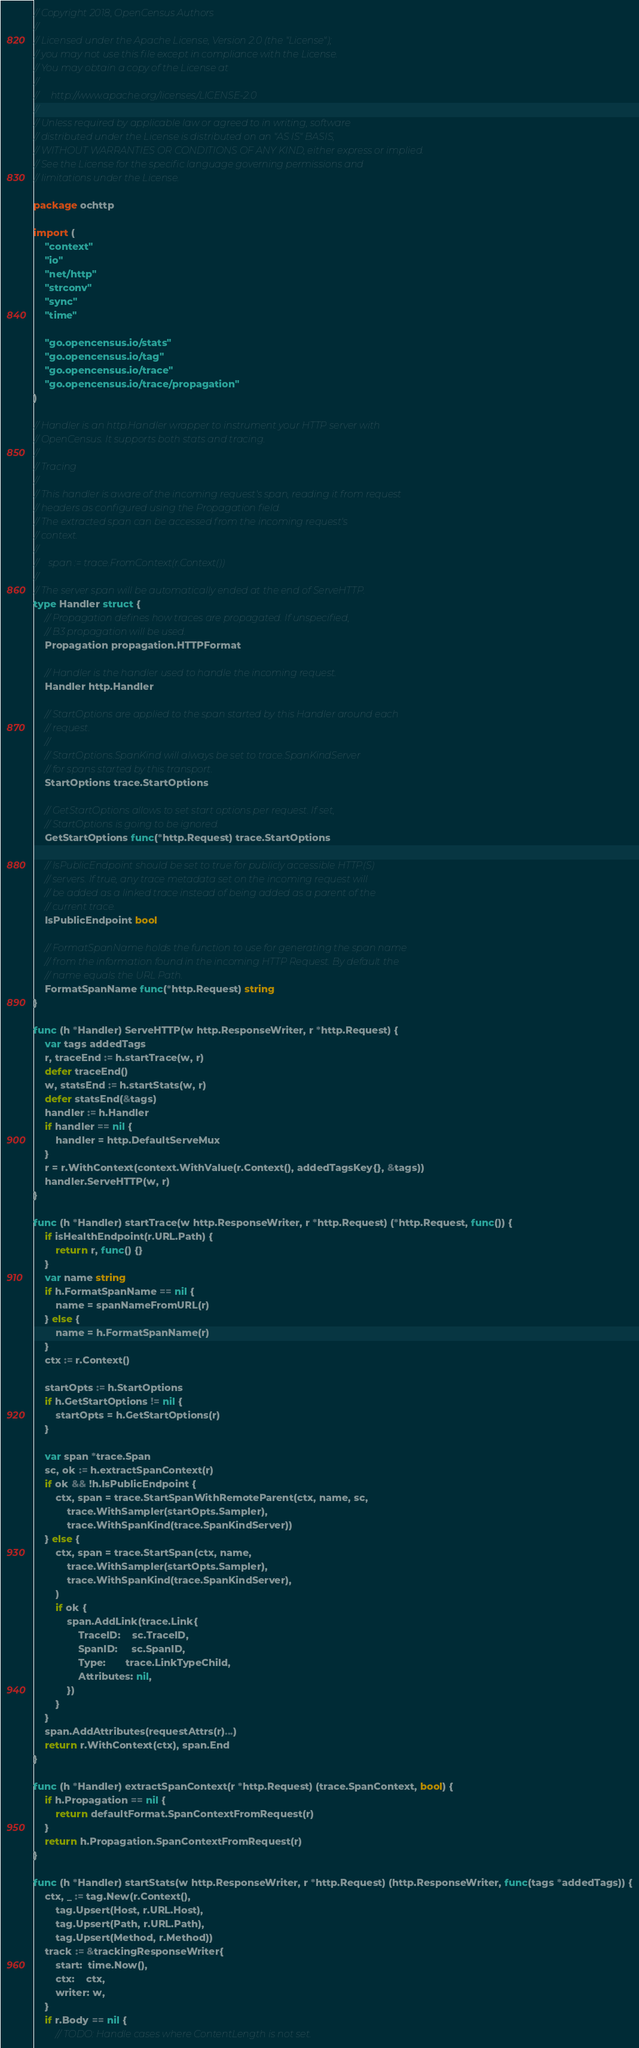<code> <loc_0><loc_0><loc_500><loc_500><_Go_>// Copyright 2018, OpenCensus Authors
//
// Licensed under the Apache License, Version 2.0 (the "License");
// you may not use this file except in compliance with the License.
// You may obtain a copy of the License at
//
//     http://www.apache.org/licenses/LICENSE-2.0
//
// Unless required by applicable law or agreed to in writing, software
// distributed under the License is distributed on an "AS IS" BASIS,
// WITHOUT WARRANTIES OR CONDITIONS OF ANY KIND, either express or implied.
// See the License for the specific language governing permissions and
// limitations under the License.

package ochttp

import (
	"context"
	"io"
	"net/http"
	"strconv"
	"sync"
	"time"

	"go.opencensus.io/stats"
	"go.opencensus.io/tag"
	"go.opencensus.io/trace"
	"go.opencensus.io/trace/propagation"
)

// Handler is an http.Handler wrapper to instrument your HTTP server with
// OpenCensus. It supports both stats and tracing.
//
// Tracing
//
// This handler is aware of the incoming request's span, reading it from request
// headers as configured using the Propagation field.
// The extracted span can be accessed from the incoming request's
// context.
//
//    span := trace.FromContext(r.Context())
//
// The server span will be automatically ended at the end of ServeHTTP.
type Handler struct {
	// Propagation defines how traces are propagated. If unspecified,
	// B3 propagation will be used.
	Propagation propagation.HTTPFormat

	// Handler is the handler used to handle the incoming request.
	Handler http.Handler

	// StartOptions are applied to the span started by this Handler around each
	// request.
	//
	// StartOptions.SpanKind will always be set to trace.SpanKindServer
	// for spans started by this transport.
	StartOptions trace.StartOptions

	// GetStartOptions allows to set start options per request. If set,
	// StartOptions is going to be ignored.
	GetStartOptions func(*http.Request) trace.StartOptions

	// IsPublicEndpoint should be set to true for publicly accessible HTTP(S)
	// servers. If true, any trace metadata set on the incoming request will
	// be added as a linked trace instead of being added as a parent of the
	// current trace.
	IsPublicEndpoint bool

	// FormatSpanName holds the function to use for generating the span name
	// from the information found in the incoming HTTP Request. By default the
	// name equals the URL Path.
	FormatSpanName func(*http.Request) string
}

func (h *Handler) ServeHTTP(w http.ResponseWriter, r *http.Request) {
	var tags addedTags
	r, traceEnd := h.startTrace(w, r)
	defer traceEnd()
	w, statsEnd := h.startStats(w, r)
	defer statsEnd(&tags)
	handler := h.Handler
	if handler == nil {
		handler = http.DefaultServeMux
	}
	r = r.WithContext(context.WithValue(r.Context(), addedTagsKey{}, &tags))
	handler.ServeHTTP(w, r)
}

func (h *Handler) startTrace(w http.ResponseWriter, r *http.Request) (*http.Request, func()) {
	if isHealthEndpoint(r.URL.Path) {
		return r, func() {}
	}
	var name string
	if h.FormatSpanName == nil {
		name = spanNameFromURL(r)
	} else {
		name = h.FormatSpanName(r)
	}
	ctx := r.Context()

	startOpts := h.StartOptions
	if h.GetStartOptions != nil {
		startOpts = h.GetStartOptions(r)
	}

	var span *trace.Span
	sc, ok := h.extractSpanContext(r)
	if ok && !h.IsPublicEndpoint {
		ctx, span = trace.StartSpanWithRemoteParent(ctx, name, sc,
			trace.WithSampler(startOpts.Sampler),
			trace.WithSpanKind(trace.SpanKindServer))
	} else {
		ctx, span = trace.StartSpan(ctx, name,
			trace.WithSampler(startOpts.Sampler),
			trace.WithSpanKind(trace.SpanKindServer),
		)
		if ok {
			span.AddLink(trace.Link{
				TraceID:    sc.TraceID,
				SpanID:     sc.SpanID,
				Type:       trace.LinkTypeChild,
				Attributes: nil,
			})
		}
	}
	span.AddAttributes(requestAttrs(r)...)
	return r.WithContext(ctx), span.End
}

func (h *Handler) extractSpanContext(r *http.Request) (trace.SpanContext, bool) {
	if h.Propagation == nil {
		return defaultFormat.SpanContextFromRequest(r)
	}
	return h.Propagation.SpanContextFromRequest(r)
}

func (h *Handler) startStats(w http.ResponseWriter, r *http.Request) (http.ResponseWriter, func(tags *addedTags)) {
	ctx, _ := tag.New(r.Context(),
		tag.Upsert(Host, r.URL.Host),
		tag.Upsert(Path, r.URL.Path),
		tag.Upsert(Method, r.Method))
	track := &trackingResponseWriter{
		start:  time.Now(),
		ctx:    ctx,
		writer: w,
	}
	if r.Body == nil {
		// TODO: Handle cases where ContentLength is not set.</code> 